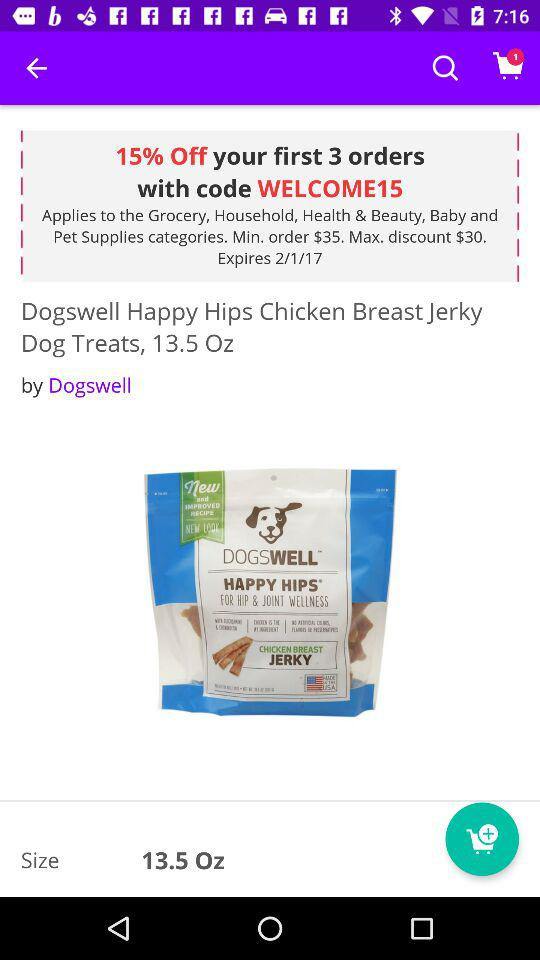How many ounces are in the dog treats?
Answer the question using a single word or phrase. 13.5 